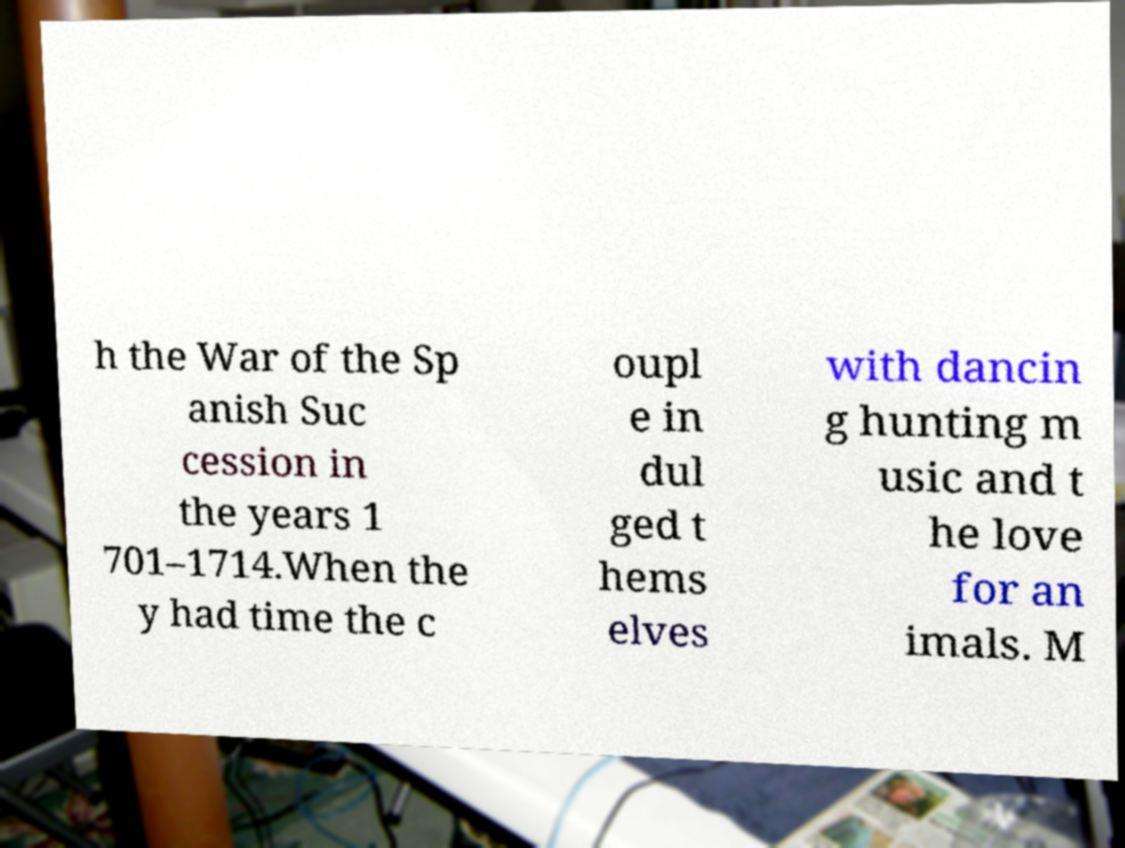I need the written content from this picture converted into text. Can you do that? h the War of the Sp anish Suc cession in the years 1 701–1714.When the y had time the c oupl e in dul ged t hems elves with dancin g hunting m usic and t he love for an imals. M 